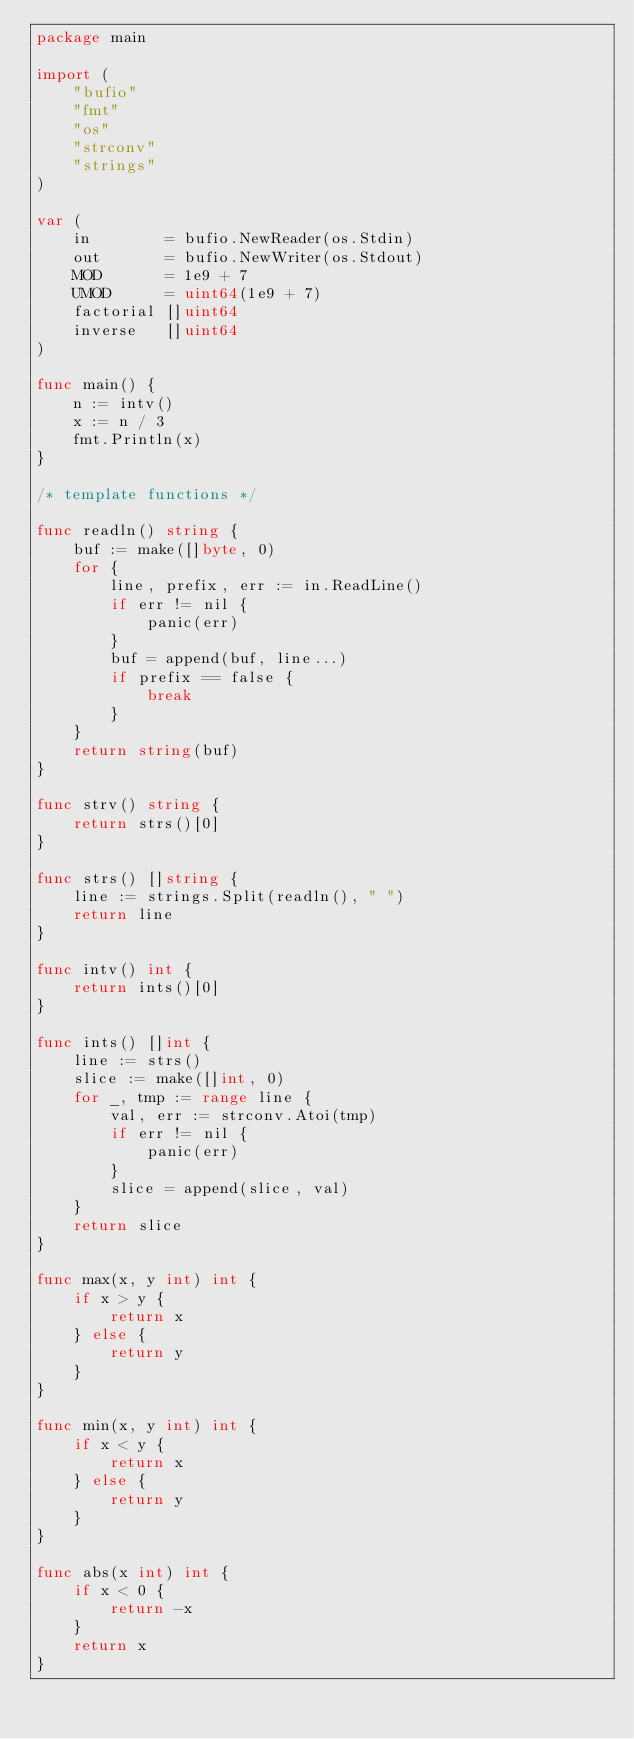<code> <loc_0><loc_0><loc_500><loc_500><_Go_>package main

import (
	"bufio"
	"fmt"
	"os"
	"strconv"
	"strings"
)

var (
	in        = bufio.NewReader(os.Stdin)
	out       = bufio.NewWriter(os.Stdout)
	MOD       = 1e9 + 7
	UMOD      = uint64(1e9 + 7)
	factorial []uint64
	inverse   []uint64
)

func main() {
	n := intv()
	x := n / 3
	fmt.Println(x)
}

/* template functions */

func readln() string {
	buf := make([]byte, 0)
	for {
		line, prefix, err := in.ReadLine()
		if err != nil {
			panic(err)
		}
		buf = append(buf, line...)
		if prefix == false {
			break
		}
	}
	return string(buf)
}

func strv() string {
	return strs()[0]
}

func strs() []string {
	line := strings.Split(readln(), " ")
	return line
}

func intv() int {
	return ints()[0]
}

func ints() []int {
	line := strs()
	slice := make([]int, 0)
	for _, tmp := range line {
		val, err := strconv.Atoi(tmp)
		if err != nil {
			panic(err)
		}
		slice = append(slice, val)
	}
	return slice
}

func max(x, y int) int {
	if x > y {
		return x
	} else {
		return y
	}
}

func min(x, y int) int {
	if x < y {
		return x
	} else {
		return y
	}
}

func abs(x int) int {
	if x < 0 {
		return -x
	}
	return x
}
</code> 